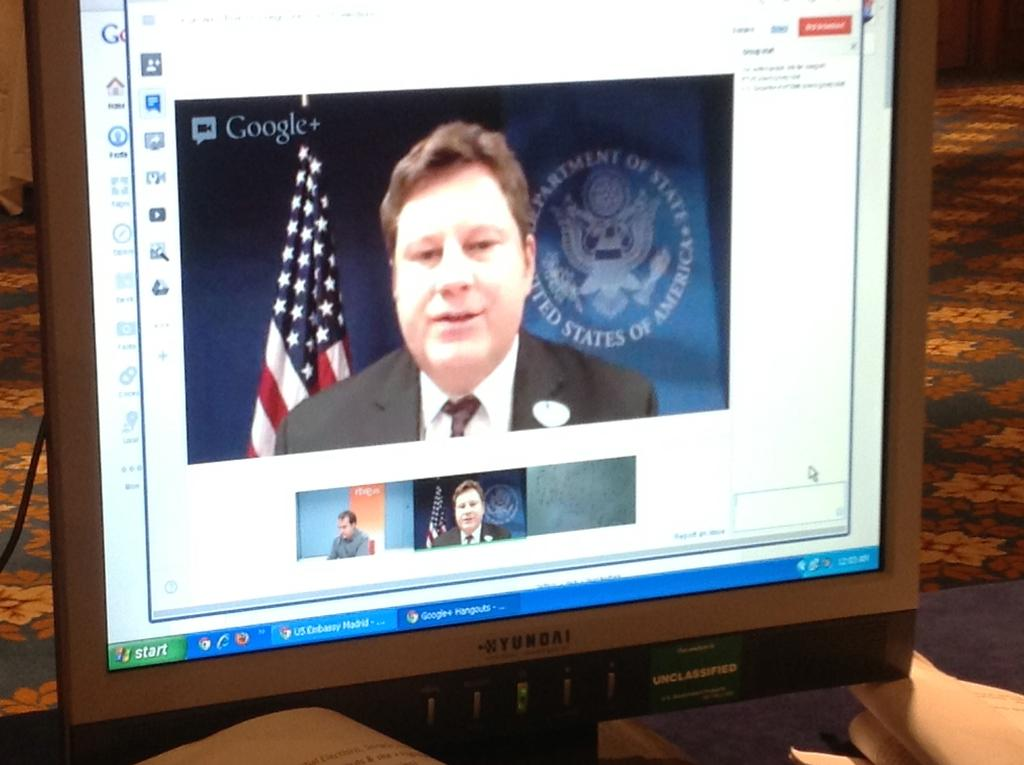<image>
Share a concise interpretation of the image provided. A Google Hangouts video call with a man in the US State Department. 